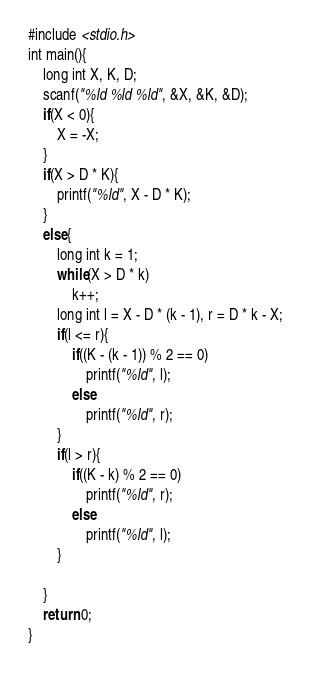Convert code to text. <code><loc_0><loc_0><loc_500><loc_500><_C_>#include <stdio.h>
int main(){
	long int X, K, D;
	scanf("%ld %ld %ld", &X, &K, &D);
	if(X < 0){
		X = -X;
	}
	if(X > D * K){
		printf("%ld", X - D * K);
	}
	else{
		long int k = 1;
		while(X > D * k)
			k++;
		long int l = X - D * (k - 1), r = D * k - X;
		if(l <= r){
			if((K - (k - 1)) % 2 == 0)
				printf("%ld", l);
			else
				printf("%ld", r);
		}
		if(l > r){
			if((K - k) % 2 == 0)
				printf("%ld", r);
			else
				printf("%ld", l);
		}
		
	}
	return 0;
}</code> 